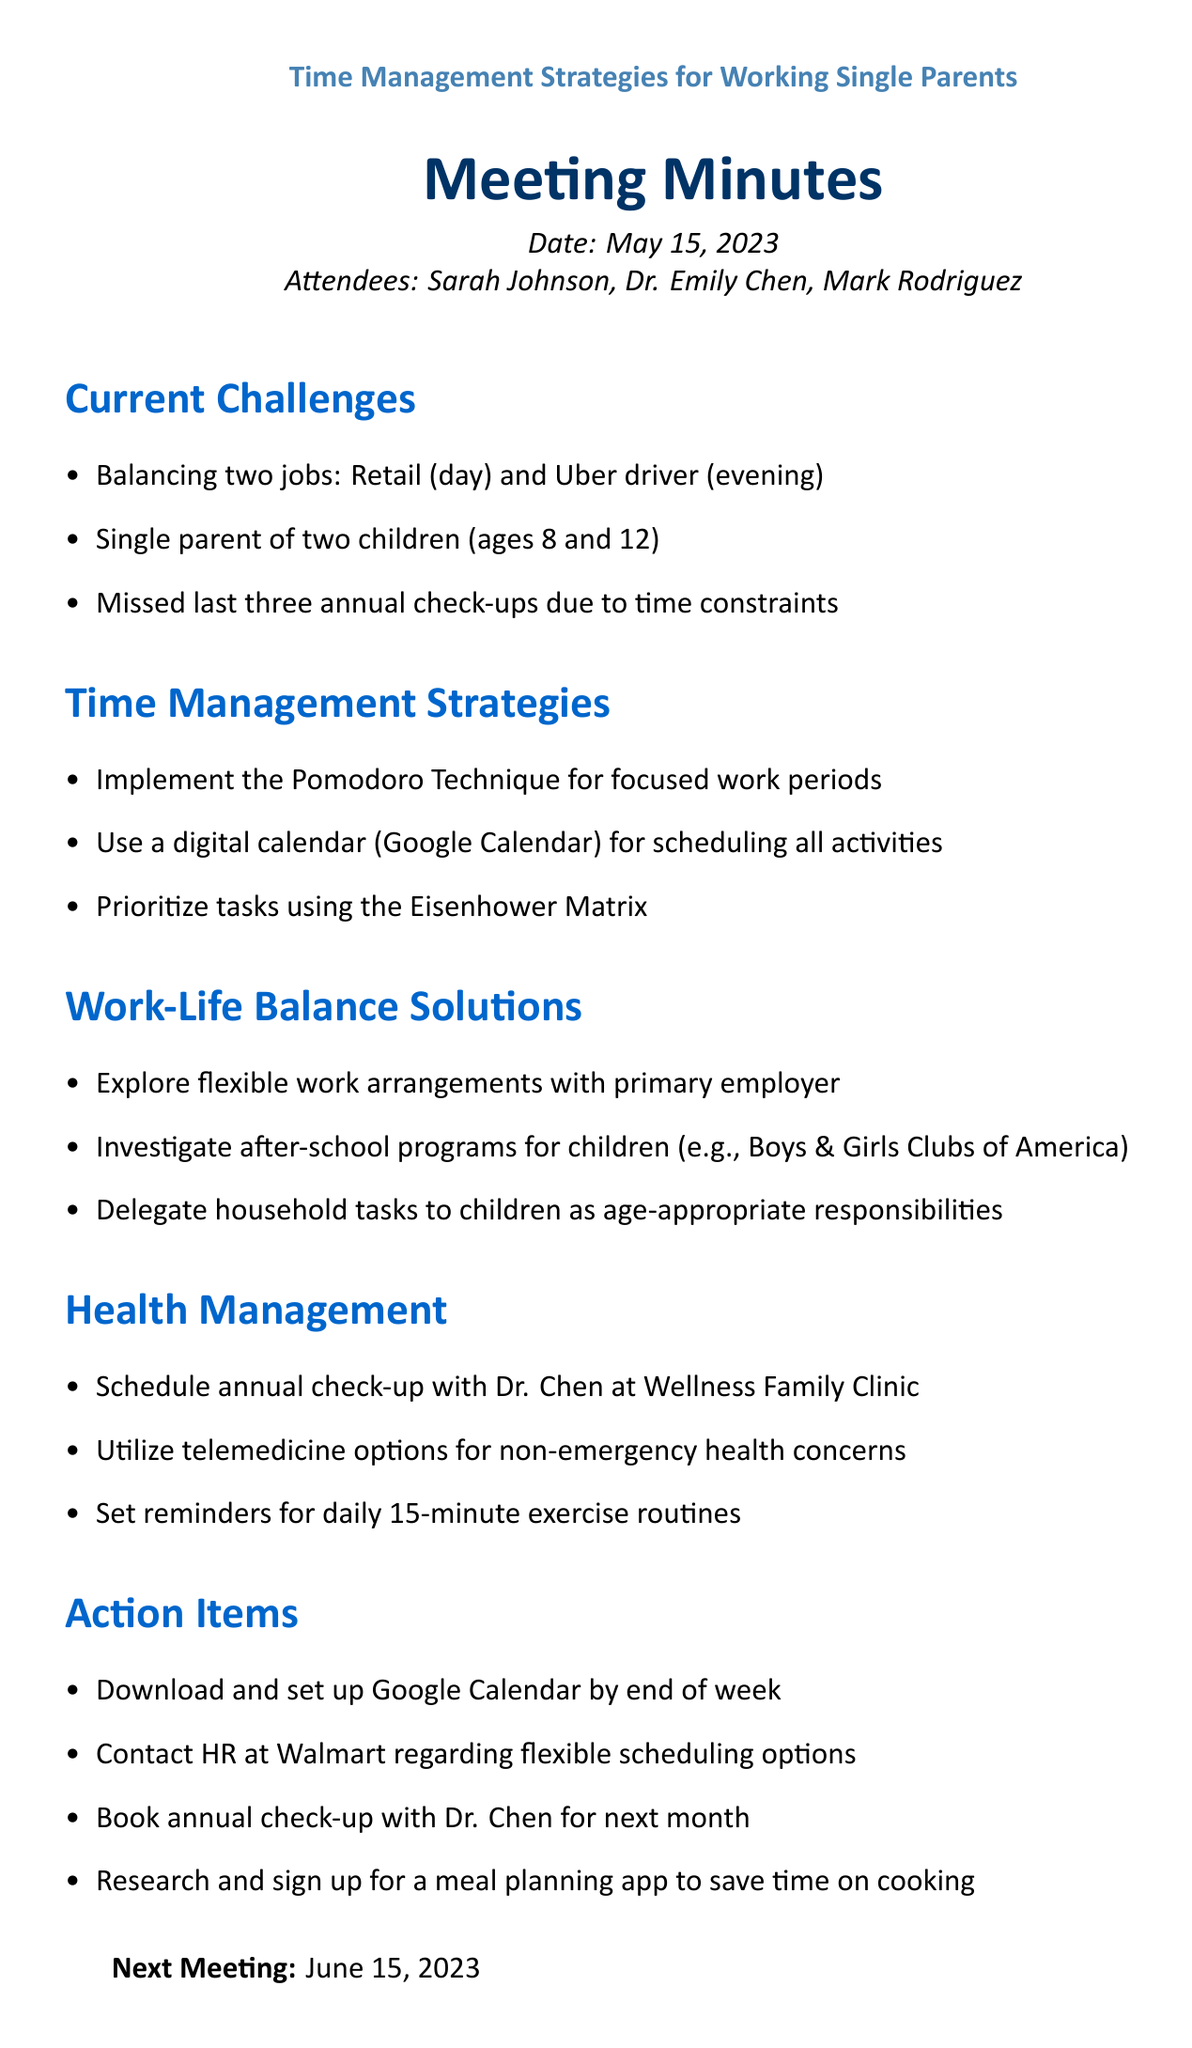What is the meeting title? The meeting title is presented at the beginning of the document, identifying the topic of discussion.
Answer: Time Management Strategies for Working Single Parents Who is one of the attendees? The list of attendees is included in the document, showing all participants present in the meeting.
Answer: Sarah Johnson What is the date of the meeting? The date of the meeting is specified near the top of the document, indicating when the meeting took place.
Answer: May 15, 2023 What time management strategy involves focused work periods? This strategy is included in the document under the "Time Management Strategies" section, detailing methods for better productivity.
Answer: Pomodoro Technique What is one proposed work-life balance solution? The document lists various solutions under the "Work-Life Balance Solutions" section for managing responsibilities.
Answer: Investigate after-school programs for children What is an action item to be completed by the end of the week? The action items are outlined clearly in the document, specifying tasks to be accomplished post-meeting.
Answer: Download and set up Google Calendar by end of week When is the next meeting scheduled? The date for the next meeting is provided at the end of the document, ensuring participants know when to reconnect.
Answer: June 15, 2023 What is a method suggested for health management? The document outlines several health management strategies aimed at promoting well-being for participants.
Answer: Schedule annual check-up with Dr. Chen What tool is recommended for scheduling activities? The document specifies tools and techniques for effective time management within the agenda.
Answer: Digital calendar (Google Calendar) 